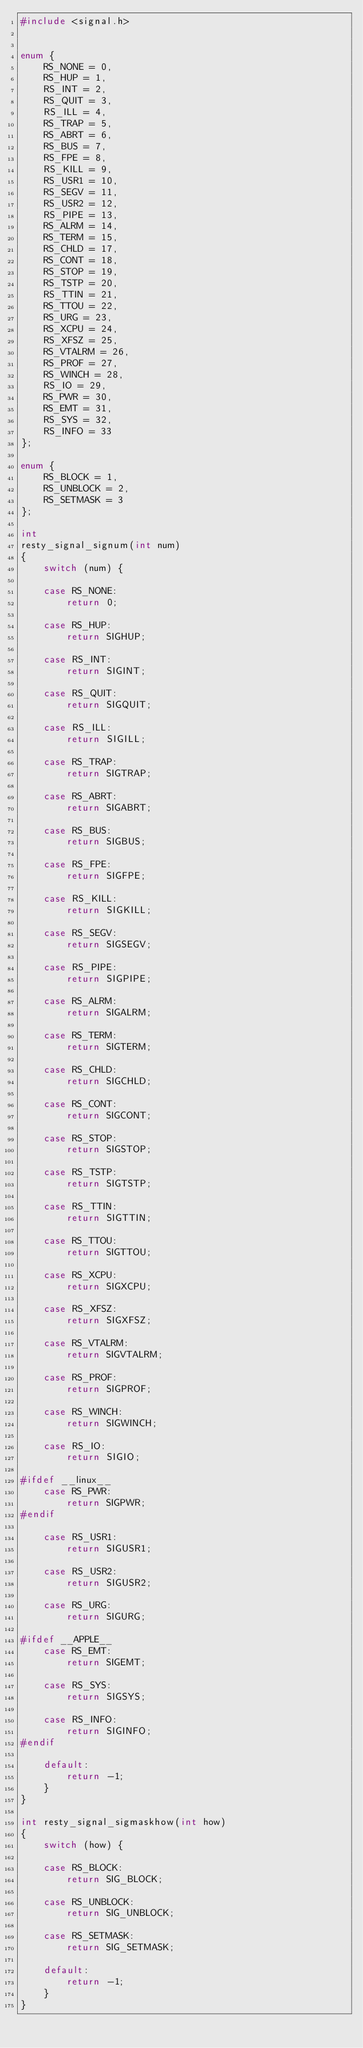Convert code to text. <code><loc_0><loc_0><loc_500><loc_500><_C_>#include <signal.h>


enum {
    RS_NONE = 0,
    RS_HUP = 1,
    RS_INT = 2,
    RS_QUIT = 3,
    RS_ILL = 4,
    RS_TRAP = 5,
    RS_ABRT = 6,
    RS_BUS = 7,
    RS_FPE = 8,
    RS_KILL = 9,
    RS_USR1 = 10,
    RS_SEGV = 11,
    RS_USR2 = 12,
    RS_PIPE = 13,
    RS_ALRM = 14,
    RS_TERM = 15,
    RS_CHLD = 17,
    RS_CONT = 18,
    RS_STOP = 19,
    RS_TSTP = 20,
    RS_TTIN = 21,
    RS_TTOU = 22,
    RS_URG = 23,
    RS_XCPU = 24,
    RS_XFSZ = 25,
    RS_VTALRM = 26,
    RS_PROF = 27,
    RS_WINCH = 28,
    RS_IO = 29,
    RS_PWR = 30,
    RS_EMT = 31,
    RS_SYS = 32,
    RS_INFO = 33
};

enum {
    RS_BLOCK = 1,
    RS_UNBLOCK = 2,
    RS_SETMASK = 3
};

int
resty_signal_signum(int num)
{
    switch (num) {

    case RS_NONE:
        return 0;

    case RS_HUP:
        return SIGHUP;

    case RS_INT:
        return SIGINT;

    case RS_QUIT:
        return SIGQUIT;

    case RS_ILL:
        return SIGILL;

    case RS_TRAP:
        return SIGTRAP;

    case RS_ABRT:
        return SIGABRT;

    case RS_BUS:
        return SIGBUS;

    case RS_FPE:
        return SIGFPE;

    case RS_KILL:
        return SIGKILL;

    case RS_SEGV:
        return SIGSEGV;

    case RS_PIPE:
        return SIGPIPE;

    case RS_ALRM:
        return SIGALRM;

    case RS_TERM:
        return SIGTERM;

    case RS_CHLD:
        return SIGCHLD;

    case RS_CONT:
        return SIGCONT;

    case RS_STOP:
        return SIGSTOP;

    case RS_TSTP:
        return SIGTSTP;

    case RS_TTIN:
        return SIGTTIN;

    case RS_TTOU:
        return SIGTTOU;

    case RS_XCPU:
        return SIGXCPU;

    case RS_XFSZ:
        return SIGXFSZ;

    case RS_VTALRM:
        return SIGVTALRM;

    case RS_PROF:
        return SIGPROF;

    case RS_WINCH:
        return SIGWINCH;

    case RS_IO:
        return SIGIO;

#ifdef __linux__
    case RS_PWR:
        return SIGPWR;
#endif

    case RS_USR1:
        return SIGUSR1;

    case RS_USR2:
        return SIGUSR2;

    case RS_URG:
        return SIGURG;

#ifdef __APPLE__
    case RS_EMT:
        return SIGEMT;

    case RS_SYS:
        return SIGSYS;

    case RS_INFO:
        return SIGINFO;
#endif

    default:
        return -1;
    }
}

int resty_signal_sigmaskhow(int how)
{
    switch (how) {

    case RS_BLOCK:
        return SIG_BLOCK;

    case RS_UNBLOCK:
        return SIG_UNBLOCK;

    case RS_SETMASK:
        return SIG_SETMASK;

    default:
        return -1;
    }
}
</code> 